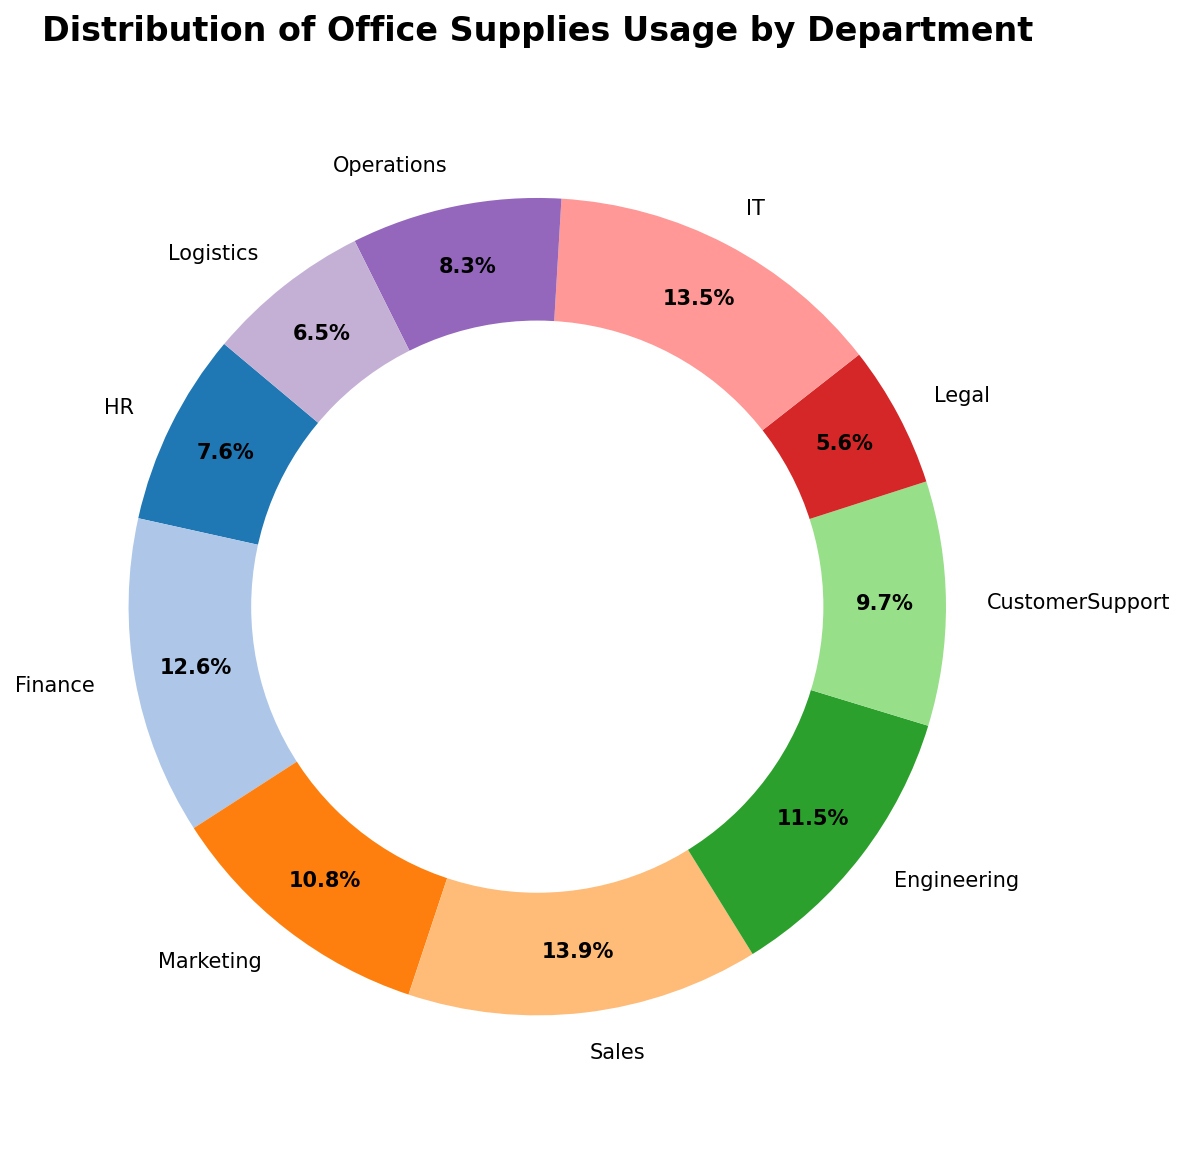Which department has the highest office supplies usage? Inspecting the ring chart, we see that the Sales department has the largest segment in terms of office supplies usage.
Answer: Sales Which department has the lowest office supplies usage? Looking at the smallest segment in the ring chart, the Legal department uses the least amount of office supplies.
Answer: Legal How much more office supplies does Sales use compared to Legal? From the chart, Sales uses 620 units, and Legal uses 250 units. The difference is 620 - 250.
Answer: 370 Which two departments have approximately equal office supplies usage? The segments for HR and Operations are visually similar in size, indicating their usage amounts are close.
Answer: HR and Operations What percentage of the total office supplies is used by the IT department? The IT department's segment shows a percentage of 18.2% in the chart.
Answer: 18.2% What is the combined office supplies usage of Marketing and Customer Support departments? Marketing uses 480 units, and Customer Support uses 430 units. Their combined usage is 480 + 430.
Answer: 910 Which department uses more office supplies, Engineering or Finance? Observing the chart, Finance has a larger segment than Engineering.
Answer: Finance What is the percentage difference in office supplies usage between IT and Operations? IT uses 600 units, and Operations uses 370 units. The percentage difference is calculated as ((600 - 370) / 370) * 100.
Answer: 62.2% Which departments' office supplies usage percentages are less than 10% each? From the chart, Legal and Logistics departments have segments that represent less than 10% each.
Answer: Legal and Logistics What is the total percentage of office supplies used by HR, Finance, and Marketing together? HR is 10.3%, Finance is 17%, and Marketing is 14.6%. Their total is 10.3 + 17 + 14.6.
Answer: 41.9% 